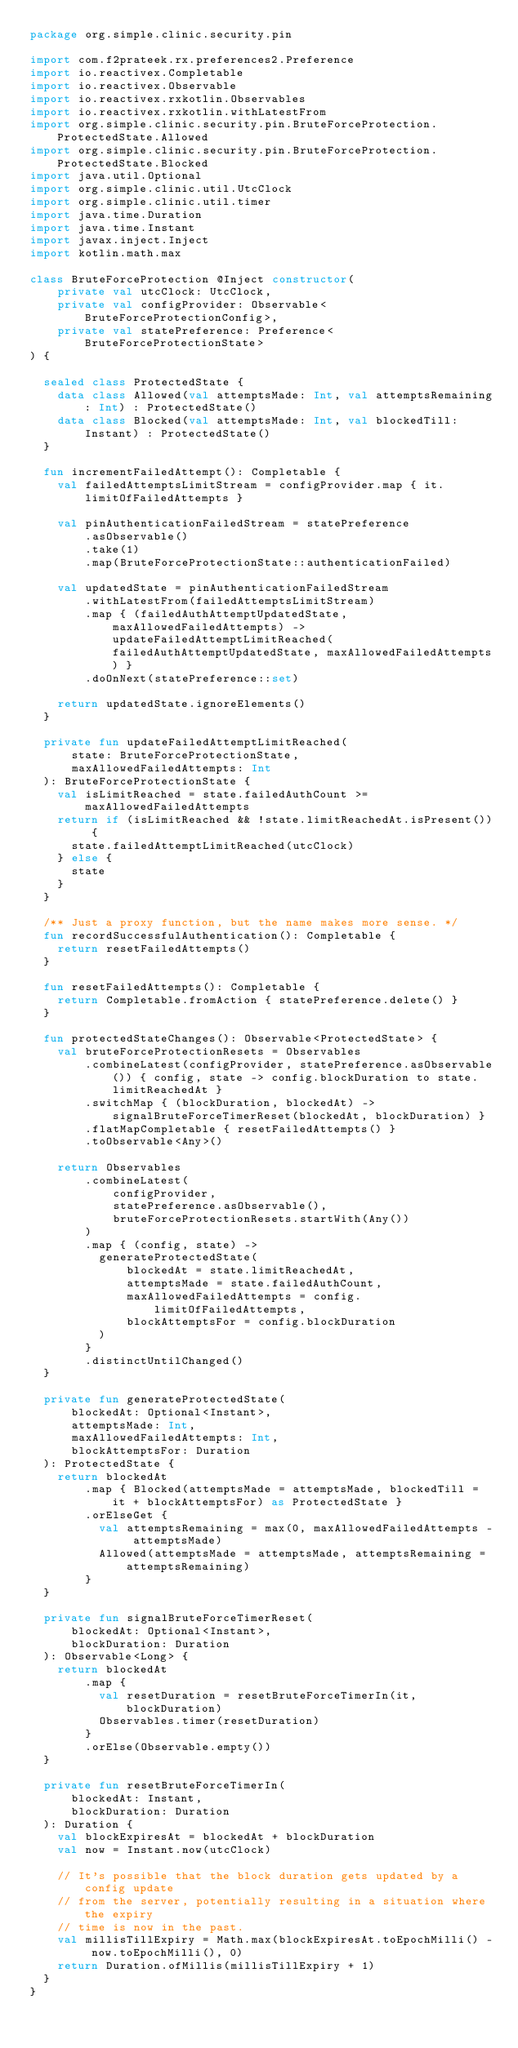Convert code to text. <code><loc_0><loc_0><loc_500><loc_500><_Kotlin_>package org.simple.clinic.security.pin

import com.f2prateek.rx.preferences2.Preference
import io.reactivex.Completable
import io.reactivex.Observable
import io.reactivex.rxkotlin.Observables
import io.reactivex.rxkotlin.withLatestFrom
import org.simple.clinic.security.pin.BruteForceProtection.ProtectedState.Allowed
import org.simple.clinic.security.pin.BruteForceProtection.ProtectedState.Blocked
import java.util.Optional
import org.simple.clinic.util.UtcClock
import org.simple.clinic.util.timer
import java.time.Duration
import java.time.Instant
import javax.inject.Inject
import kotlin.math.max

class BruteForceProtection @Inject constructor(
    private val utcClock: UtcClock,
    private val configProvider: Observable<BruteForceProtectionConfig>,
    private val statePreference: Preference<BruteForceProtectionState>
) {

  sealed class ProtectedState {
    data class Allowed(val attemptsMade: Int, val attemptsRemaining: Int) : ProtectedState()
    data class Blocked(val attemptsMade: Int, val blockedTill: Instant) : ProtectedState()
  }

  fun incrementFailedAttempt(): Completable {
    val failedAttemptsLimitStream = configProvider.map { it.limitOfFailedAttempts }

    val pinAuthenticationFailedStream = statePreference
        .asObservable()
        .take(1)
        .map(BruteForceProtectionState::authenticationFailed)

    val updatedState = pinAuthenticationFailedStream
        .withLatestFrom(failedAttemptsLimitStream)
        .map { (failedAuthAttemptUpdatedState, maxAllowedFailedAttempts) -> updateFailedAttemptLimitReached(failedAuthAttemptUpdatedState, maxAllowedFailedAttempts) }
        .doOnNext(statePreference::set)

    return updatedState.ignoreElements()
  }

  private fun updateFailedAttemptLimitReached(
      state: BruteForceProtectionState,
      maxAllowedFailedAttempts: Int
  ): BruteForceProtectionState {
    val isLimitReached = state.failedAuthCount >= maxAllowedFailedAttempts
    return if (isLimitReached && !state.limitReachedAt.isPresent()) {
      state.failedAttemptLimitReached(utcClock)
    } else {
      state
    }
  }

  /** Just a proxy function, but the name makes more sense. */
  fun recordSuccessfulAuthentication(): Completable {
    return resetFailedAttempts()
  }

  fun resetFailedAttempts(): Completable {
    return Completable.fromAction { statePreference.delete() }
  }

  fun protectedStateChanges(): Observable<ProtectedState> {
    val bruteForceProtectionResets = Observables
        .combineLatest(configProvider, statePreference.asObservable()) { config, state -> config.blockDuration to state.limitReachedAt }
        .switchMap { (blockDuration, blockedAt) -> signalBruteForceTimerReset(blockedAt, blockDuration) }
        .flatMapCompletable { resetFailedAttempts() }
        .toObservable<Any>()

    return Observables
        .combineLatest(
            configProvider,
            statePreference.asObservable(),
            bruteForceProtectionResets.startWith(Any())
        )
        .map { (config, state) ->
          generateProtectedState(
              blockedAt = state.limitReachedAt,
              attemptsMade = state.failedAuthCount,
              maxAllowedFailedAttempts = config.limitOfFailedAttempts,
              blockAttemptsFor = config.blockDuration
          )
        }
        .distinctUntilChanged()
  }

  private fun generateProtectedState(
      blockedAt: Optional<Instant>,
      attemptsMade: Int,
      maxAllowedFailedAttempts: Int,
      blockAttemptsFor: Duration
  ): ProtectedState {
    return blockedAt
        .map { Blocked(attemptsMade = attemptsMade, blockedTill = it + blockAttemptsFor) as ProtectedState }
        .orElseGet {
          val attemptsRemaining = max(0, maxAllowedFailedAttempts - attemptsMade)
          Allowed(attemptsMade = attemptsMade, attemptsRemaining = attemptsRemaining)
        }
  }

  private fun signalBruteForceTimerReset(
      blockedAt: Optional<Instant>,
      blockDuration: Duration
  ): Observable<Long> {
    return blockedAt
        .map {
          val resetDuration = resetBruteForceTimerIn(it, blockDuration)
          Observables.timer(resetDuration)
        }
        .orElse(Observable.empty())
  }

  private fun resetBruteForceTimerIn(
      blockedAt: Instant,
      blockDuration: Duration
  ): Duration {
    val blockExpiresAt = blockedAt + blockDuration
    val now = Instant.now(utcClock)

    // It's possible that the block duration gets updated by a config update
    // from the server, potentially resulting in a situation where the expiry
    // time is now in the past.
    val millisTillExpiry = Math.max(blockExpiresAt.toEpochMilli() - now.toEpochMilli(), 0)
    return Duration.ofMillis(millisTillExpiry + 1)
  }
}
</code> 